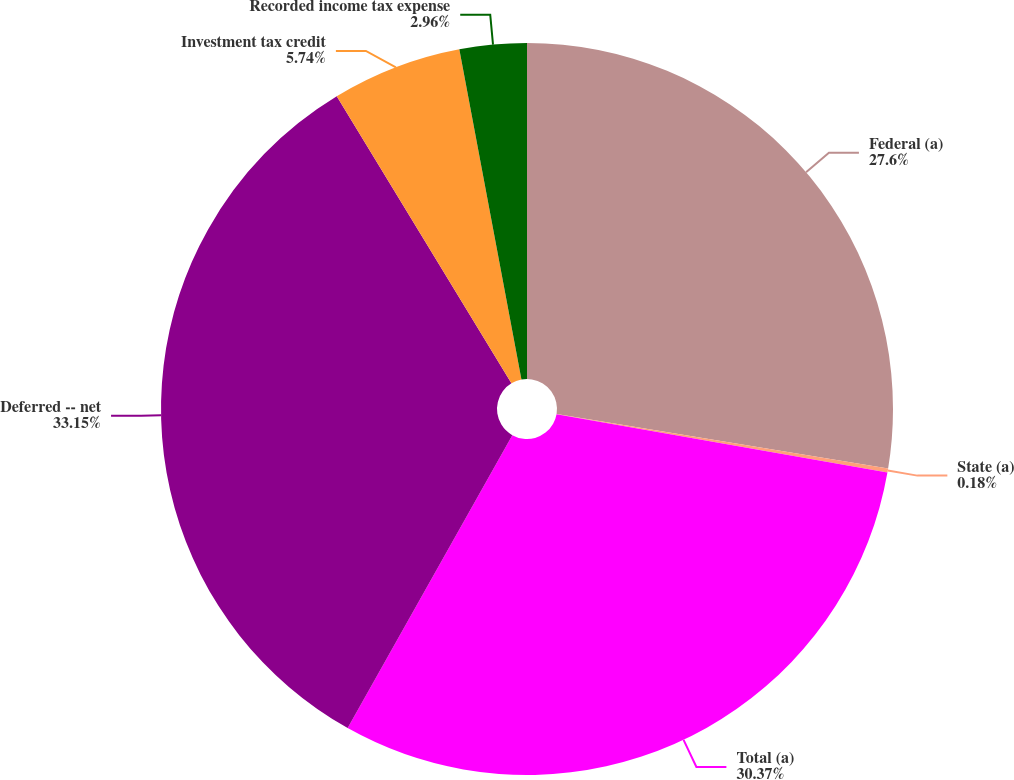Convert chart. <chart><loc_0><loc_0><loc_500><loc_500><pie_chart><fcel>Federal (a)<fcel>State (a)<fcel>Total (a)<fcel>Deferred -- net<fcel>Investment tax credit<fcel>Recorded income tax expense<nl><fcel>27.6%<fcel>0.18%<fcel>30.37%<fcel>33.15%<fcel>5.74%<fcel>2.96%<nl></chart> 